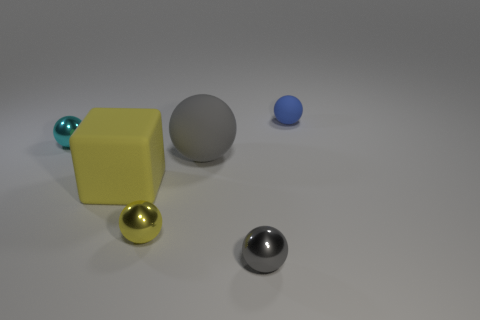Subtract all green cylinders. How many gray spheres are left? 2 Subtract all blue rubber balls. How many balls are left? 4 Add 2 cyan balls. How many objects exist? 8 Subtract all blue balls. How many balls are left? 4 Add 4 big yellow matte blocks. How many big yellow matte blocks are left? 5 Add 3 large green metal things. How many large green metal things exist? 3 Subtract 1 cyan spheres. How many objects are left? 5 Subtract all balls. How many objects are left? 1 Subtract all blue spheres. Subtract all brown cylinders. How many spheres are left? 4 Subtract all big yellow metallic spheres. Subtract all big gray things. How many objects are left? 5 